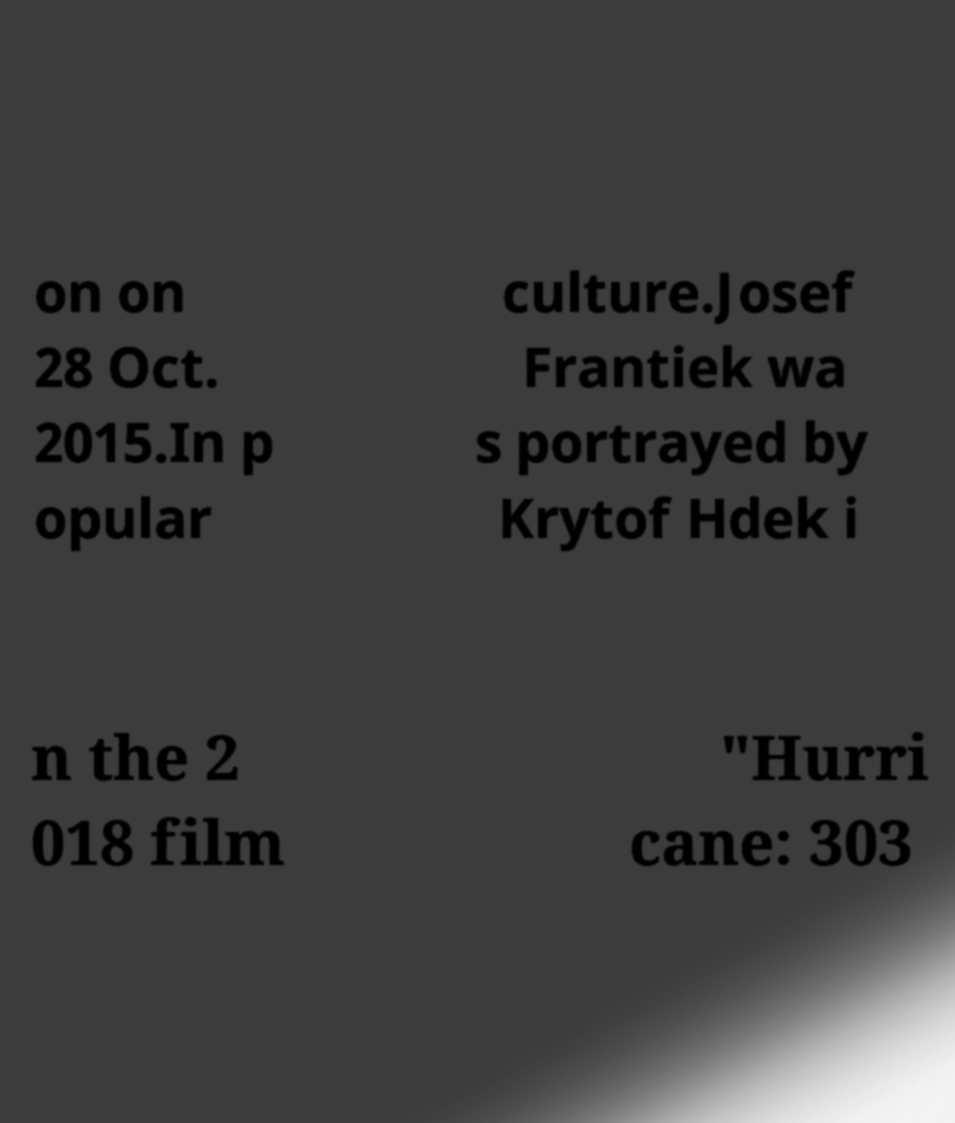What messages or text are displayed in this image? I need them in a readable, typed format. on on 28 Oct. 2015.In p opular culture.Josef Frantiek wa s portrayed by Krytof Hdek i n the 2 018 film "Hurri cane: 303 